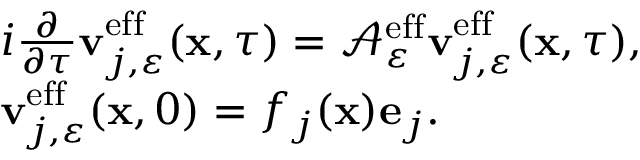<formula> <loc_0><loc_0><loc_500><loc_500>\begin{array} { r l } & { i \frac { \partial } { \partial \tau } v _ { j , \varepsilon } ^ { e f f } ( x , \tau ) = \mathcal { A } _ { \varepsilon } ^ { e f f } v _ { j , \varepsilon } ^ { e f f } ( x , \tau ) , } \\ & { v _ { j , \varepsilon } ^ { e f f } ( x , 0 ) = f _ { j } ( x ) e _ { j } . } \end{array}</formula> 